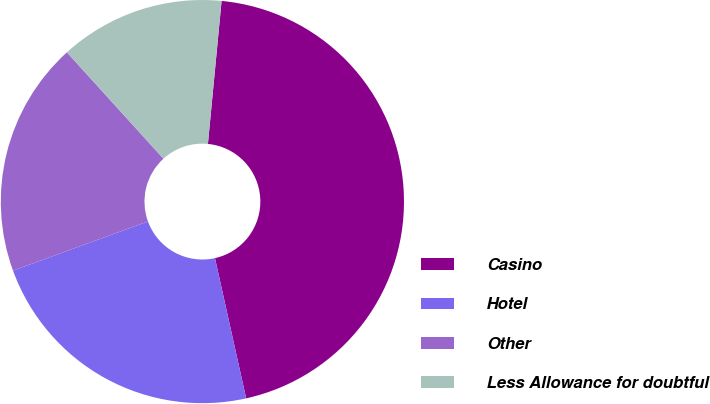<chart> <loc_0><loc_0><loc_500><loc_500><pie_chart><fcel>Casino<fcel>Hotel<fcel>Other<fcel>Less Allowance for doubtful<nl><fcel>45.0%<fcel>22.92%<fcel>18.83%<fcel>13.25%<nl></chart> 